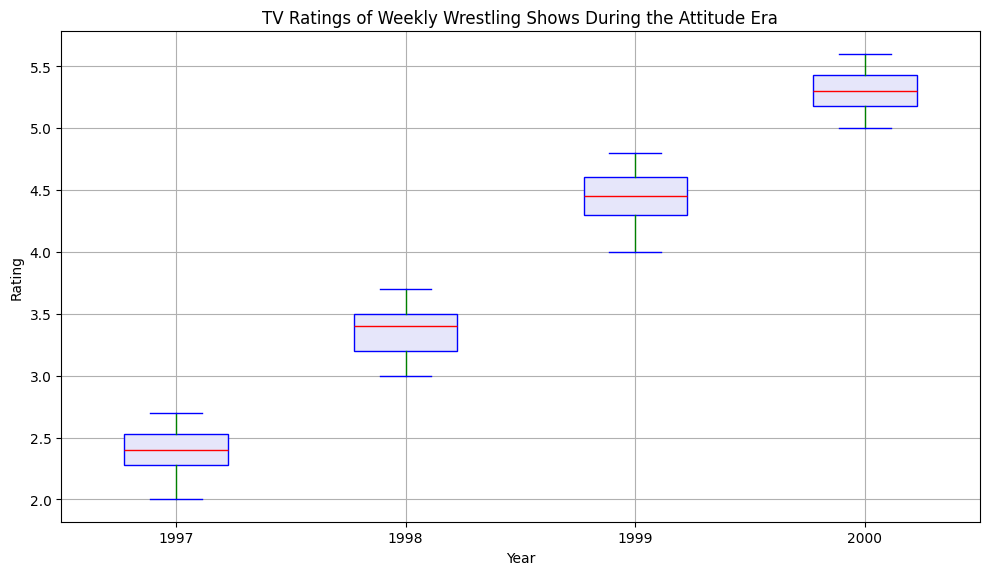What's the median TV rating for the year 1999? Look at the box plot for the year 1999. The median line within the box represents the middle value, and it's located around 4.4.
Answer: 4.4 How do the TV ratings in 1997 compare to 2000? The boxes show the distribution of TV ratings. The 1997 ratings are lower, centered around the 2.4 mark, whereas the 2000 ratings are higher with a median of about 5.3.
Answer: 1997 ratings are lower than 2000 ratings Which year has the highest median TV rating? Examine the median lines within the boxes across all years. The highest median appears in the year 2000.
Answer: 2000 What is the interquartile range (IQR) for the year 1998? The IQR is the difference between the third quartile (Q3) and the first quartile (Q1). In the 1998 boxplot, it ranges approximately from 3.2 to 3.5. Subtracting these gives an IQR of 0.3.
Answer: 0.3 How do the spreads of TV ratings compare between 1997 and 1999? The boxes' heights indicate the spread. The 1997 box is shorter, meaning less spread, while 1999 has a taller box, indicating more spread of ratings.
Answer: 1999 has a greater spread What unusual observations or outliers are present in the data? Look for points beyond the whiskers. There are black dots (outliers) in 1998, indicating some unusually high or low ratings compared to the rest of the data.
Answer: Outliers in 1998 Which year shows the most stable TV ratings? Stability can be judged by the shortest box and whiskers. The plot for 2000 has shorter whiskers and a smaller box width compared to other years, indicating more stable ratings.
Answer: 2000 Describe the change in TV ratings from 1997 to 1998. Compare both median values and spread. The median rating increased significantly from around 2.4 in 1997 to around 3.4 in 1998, showing a rise in ratings.
Answer: Increase What can be inferred about TV ratings’ consistency in 1999 compared to 1998? The height of the box and whiskers in 1999 is higher than in 1998, indicating less consistency in 1999 compared to the relatively more uniform ratings in 1998.
Answer: Less consistent in 1999 Which year saw the greatest improvement in median TV ratings from the previous year? Compare the difference between medians of successive years. The largest increase is seen from 1997 to 1998, where the median jumps from around 2.4 to around 3.4.
Answer: 1998 